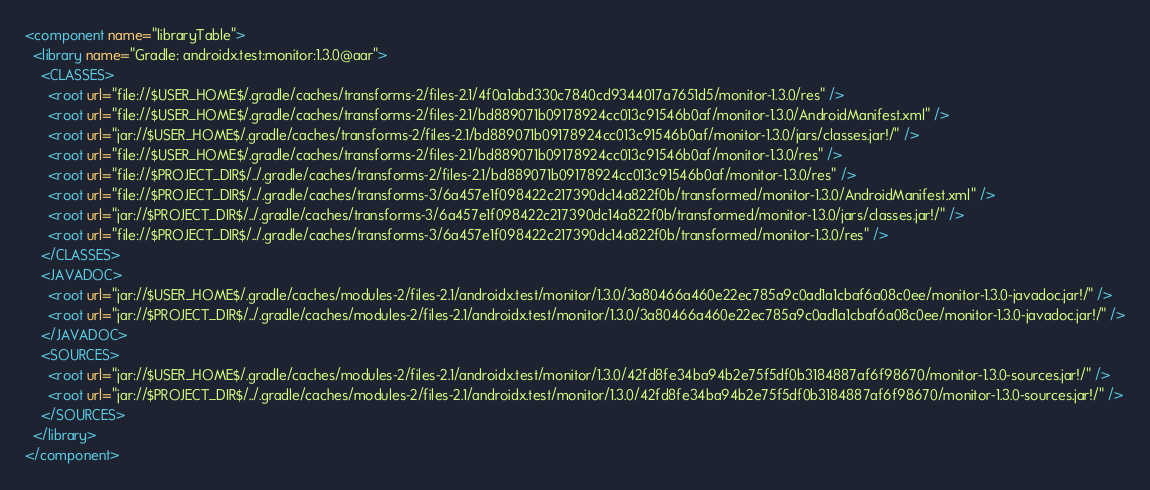Convert code to text. <code><loc_0><loc_0><loc_500><loc_500><_XML_><component name="libraryTable">
  <library name="Gradle: androidx.test:monitor:1.3.0@aar">
    <CLASSES>
      <root url="file://$USER_HOME$/.gradle/caches/transforms-2/files-2.1/4f0a1abd330c7840cd9344017a7651d5/monitor-1.3.0/res" />
      <root url="file://$USER_HOME$/.gradle/caches/transforms-2/files-2.1/bd889071b09178924cc013c91546b0af/monitor-1.3.0/AndroidManifest.xml" />
      <root url="jar://$USER_HOME$/.gradle/caches/transforms-2/files-2.1/bd889071b09178924cc013c91546b0af/monitor-1.3.0/jars/classes.jar!/" />
      <root url="file://$USER_HOME$/.gradle/caches/transforms-2/files-2.1/bd889071b09178924cc013c91546b0af/monitor-1.3.0/res" />
      <root url="file://$PROJECT_DIR$/../.gradle/caches/transforms-2/files-2.1/bd889071b09178924cc013c91546b0af/monitor-1.3.0/res" />
      <root url="file://$PROJECT_DIR$/../.gradle/caches/transforms-3/6a457e1f098422c217390dc14a822f0b/transformed/monitor-1.3.0/AndroidManifest.xml" />
      <root url="jar://$PROJECT_DIR$/../.gradle/caches/transforms-3/6a457e1f098422c217390dc14a822f0b/transformed/monitor-1.3.0/jars/classes.jar!/" />
      <root url="file://$PROJECT_DIR$/../.gradle/caches/transforms-3/6a457e1f098422c217390dc14a822f0b/transformed/monitor-1.3.0/res" />
    </CLASSES>
    <JAVADOC>
      <root url="jar://$USER_HOME$/.gradle/caches/modules-2/files-2.1/androidx.test/monitor/1.3.0/3a80466a460e22ec785a9c0ad1a1cbaf6a08c0ee/monitor-1.3.0-javadoc.jar!/" />
      <root url="jar://$PROJECT_DIR$/../.gradle/caches/modules-2/files-2.1/androidx.test/monitor/1.3.0/3a80466a460e22ec785a9c0ad1a1cbaf6a08c0ee/monitor-1.3.0-javadoc.jar!/" />
    </JAVADOC>
    <SOURCES>
      <root url="jar://$USER_HOME$/.gradle/caches/modules-2/files-2.1/androidx.test/monitor/1.3.0/42fd8fe34ba94b2e75f5df0b3184887af6f98670/monitor-1.3.0-sources.jar!/" />
      <root url="jar://$PROJECT_DIR$/../.gradle/caches/modules-2/files-2.1/androidx.test/monitor/1.3.0/42fd8fe34ba94b2e75f5df0b3184887af6f98670/monitor-1.3.0-sources.jar!/" />
    </SOURCES>
  </library>
</component></code> 